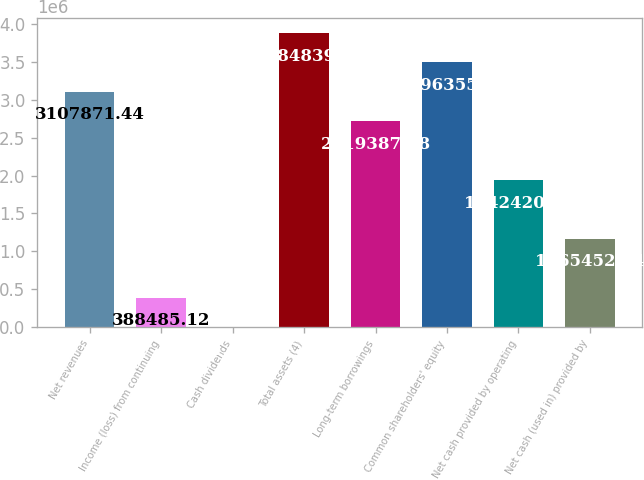Convert chart. <chart><loc_0><loc_0><loc_500><loc_500><bar_chart><fcel>Net revenues<fcel>Income (loss) from continuing<fcel>Cash dividends<fcel>Total assets (4)<fcel>Long-term borrowings<fcel>Common shareholders' equity<fcel>Net cash provided by operating<fcel>Net cash (used in) provided by<nl><fcel>3.10787e+06<fcel>388485<fcel>1.36<fcel>3.88484e+06<fcel>2.71939e+06<fcel>3.49636e+06<fcel>1.94242e+06<fcel>1.16545e+06<nl></chart> 